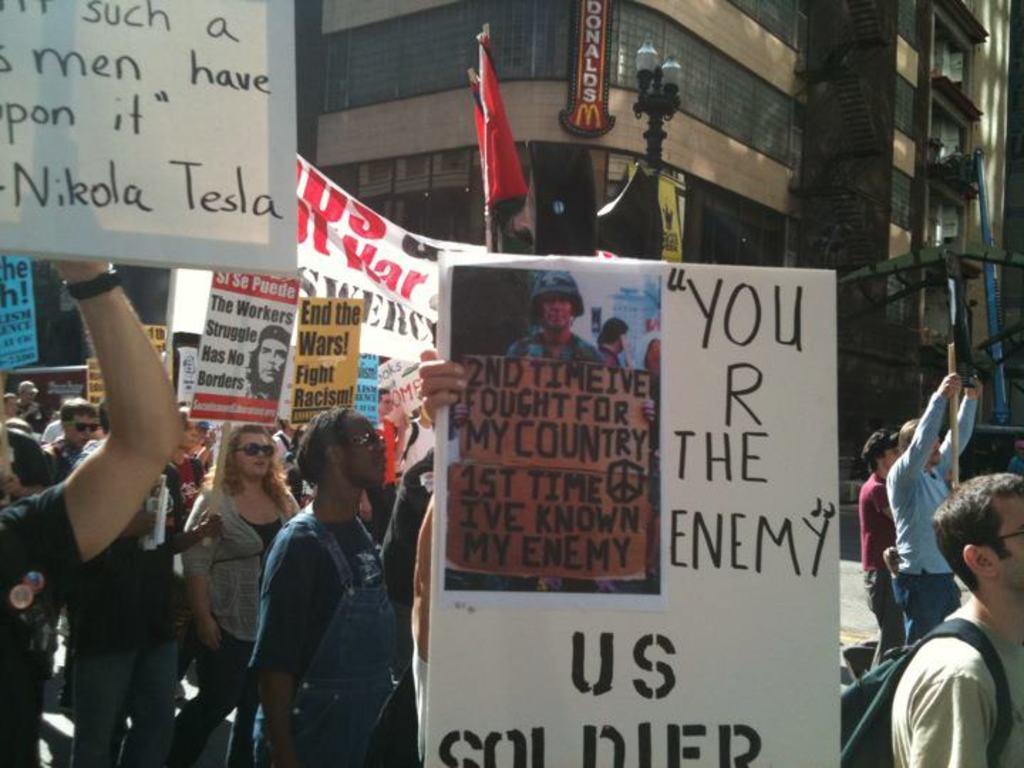Describe this image in one or two sentences. In this image, we can see people wearing glasses and some are holding boards and banners and some other objects we can see a person wearing a bag. In the background, there are buildings and we can see some lights, flags and a pole. 